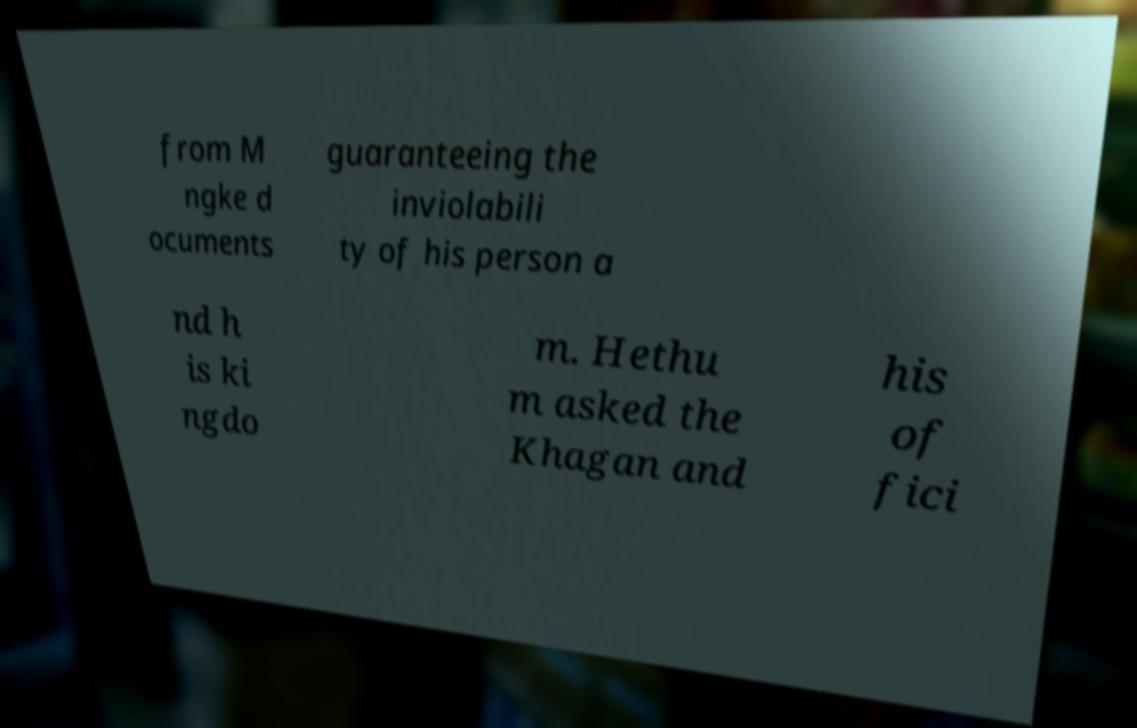I need the written content from this picture converted into text. Can you do that? from M ngke d ocuments guaranteeing the inviolabili ty of his person a nd h is ki ngdo m. Hethu m asked the Khagan and his of fici 